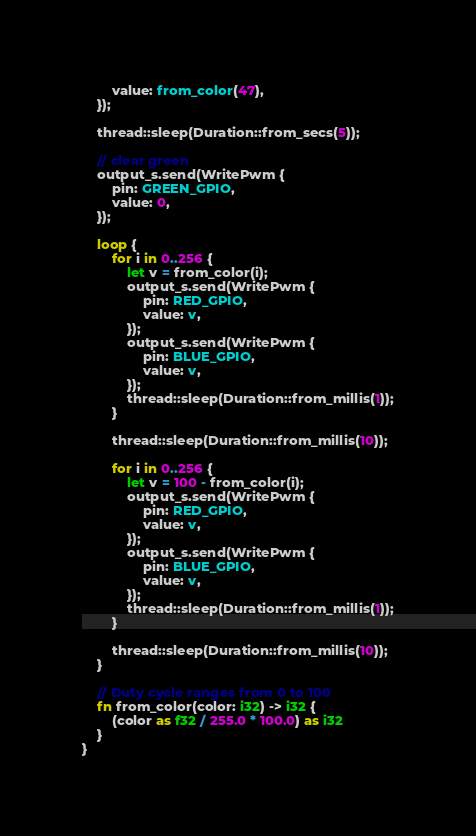<code> <loc_0><loc_0><loc_500><loc_500><_Rust_>        value: from_color(47),
    });

    thread::sleep(Duration::from_secs(5));

    // clear green
    output_s.send(WritePwm {
        pin: GREEN_GPIO,
        value: 0,
    });

    loop {
        for i in 0..256 {
            let v = from_color(i);
            output_s.send(WritePwm {
                pin: RED_GPIO,
                value: v,
            });
            output_s.send(WritePwm {
                pin: BLUE_GPIO,
                value: v,
            });
            thread::sleep(Duration::from_millis(1));
        }

        thread::sleep(Duration::from_millis(10));

        for i in 0..256 {
            let v = 100 - from_color(i);
            output_s.send(WritePwm {
                pin: RED_GPIO,
                value: v,
            });
            output_s.send(WritePwm {
                pin: BLUE_GPIO,
                value: v,
            });
            thread::sleep(Duration::from_millis(1));
        }

        thread::sleep(Duration::from_millis(10));
    }

    // Duty cycle ranges from 0 to 100
    fn from_color(color: i32) -> i32 {
        (color as f32 / 255.0 * 100.0) as i32
    }
}
</code> 